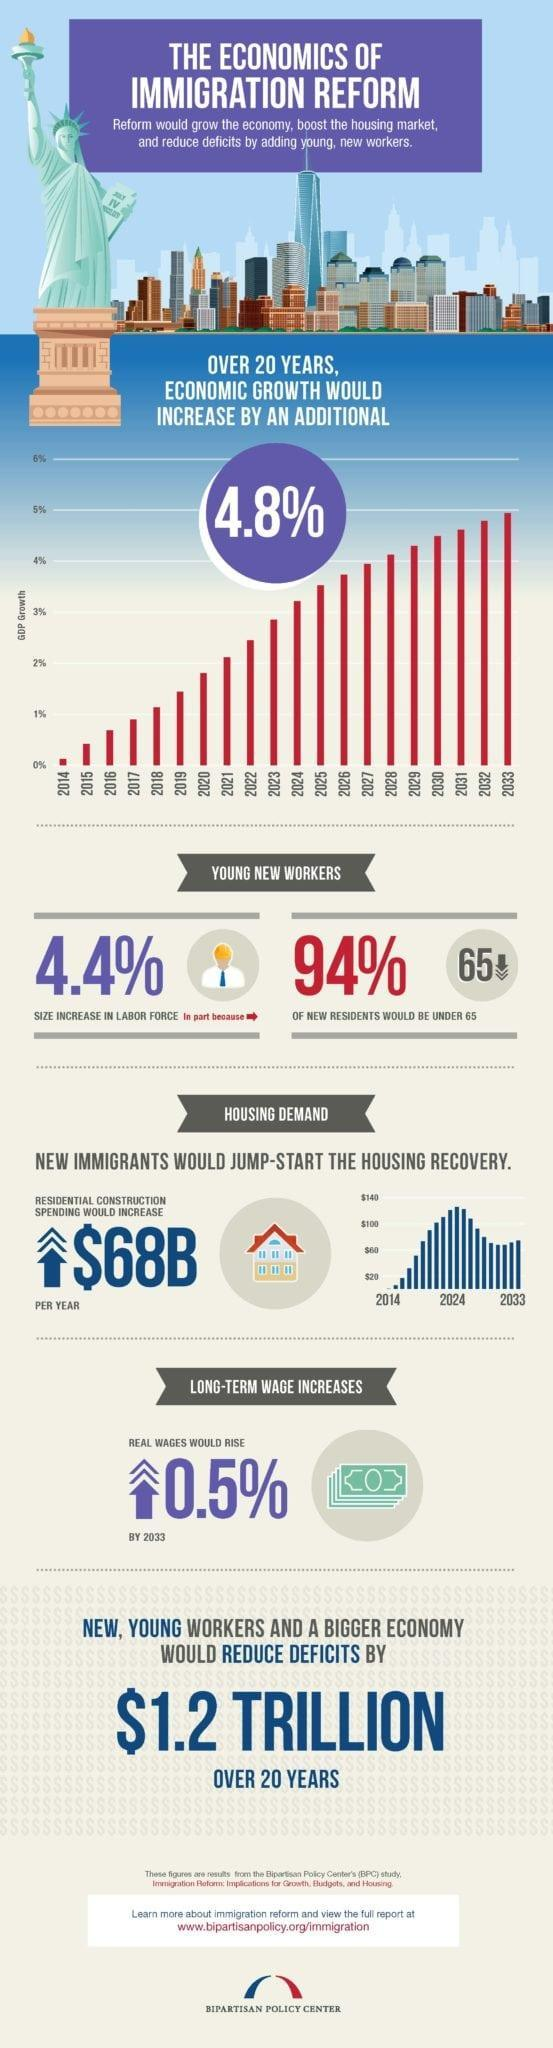What will be the increase in rate of economic growth in 20 years?
Answer the question with a short phrase. 4.8% When is the housing demand expected to be high? 2024 